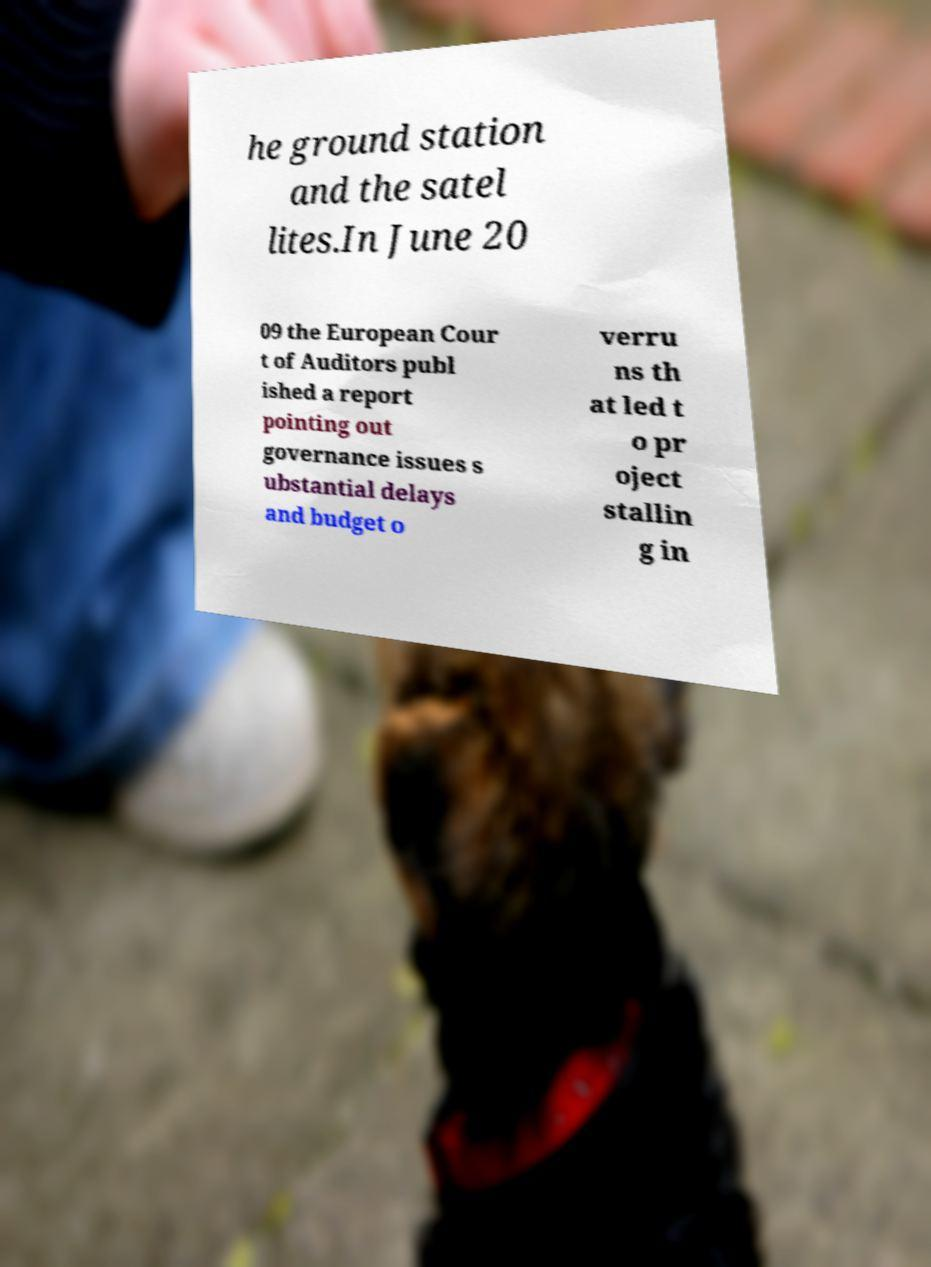For documentation purposes, I need the text within this image transcribed. Could you provide that? he ground station and the satel lites.In June 20 09 the European Cour t of Auditors publ ished a report pointing out governance issues s ubstantial delays and budget o verru ns th at led t o pr oject stallin g in 